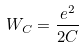Convert formula to latex. <formula><loc_0><loc_0><loc_500><loc_500>W _ { C } = \frac { e ^ { 2 } } { 2 C }</formula> 